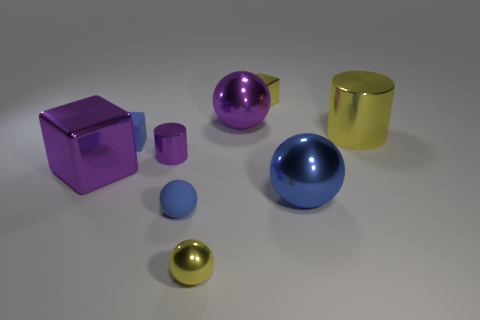Are there patterns or consistencies in the arrangement of objects in this image? Yes, there is a clear pattern of size gradation among objects with similar shapes. Each type of object—cubes, spheres, and cylinders—comes in a large, medium, and small size, creating a visually satisfying pattern that also reflects a mathematical concept known as scaling. 